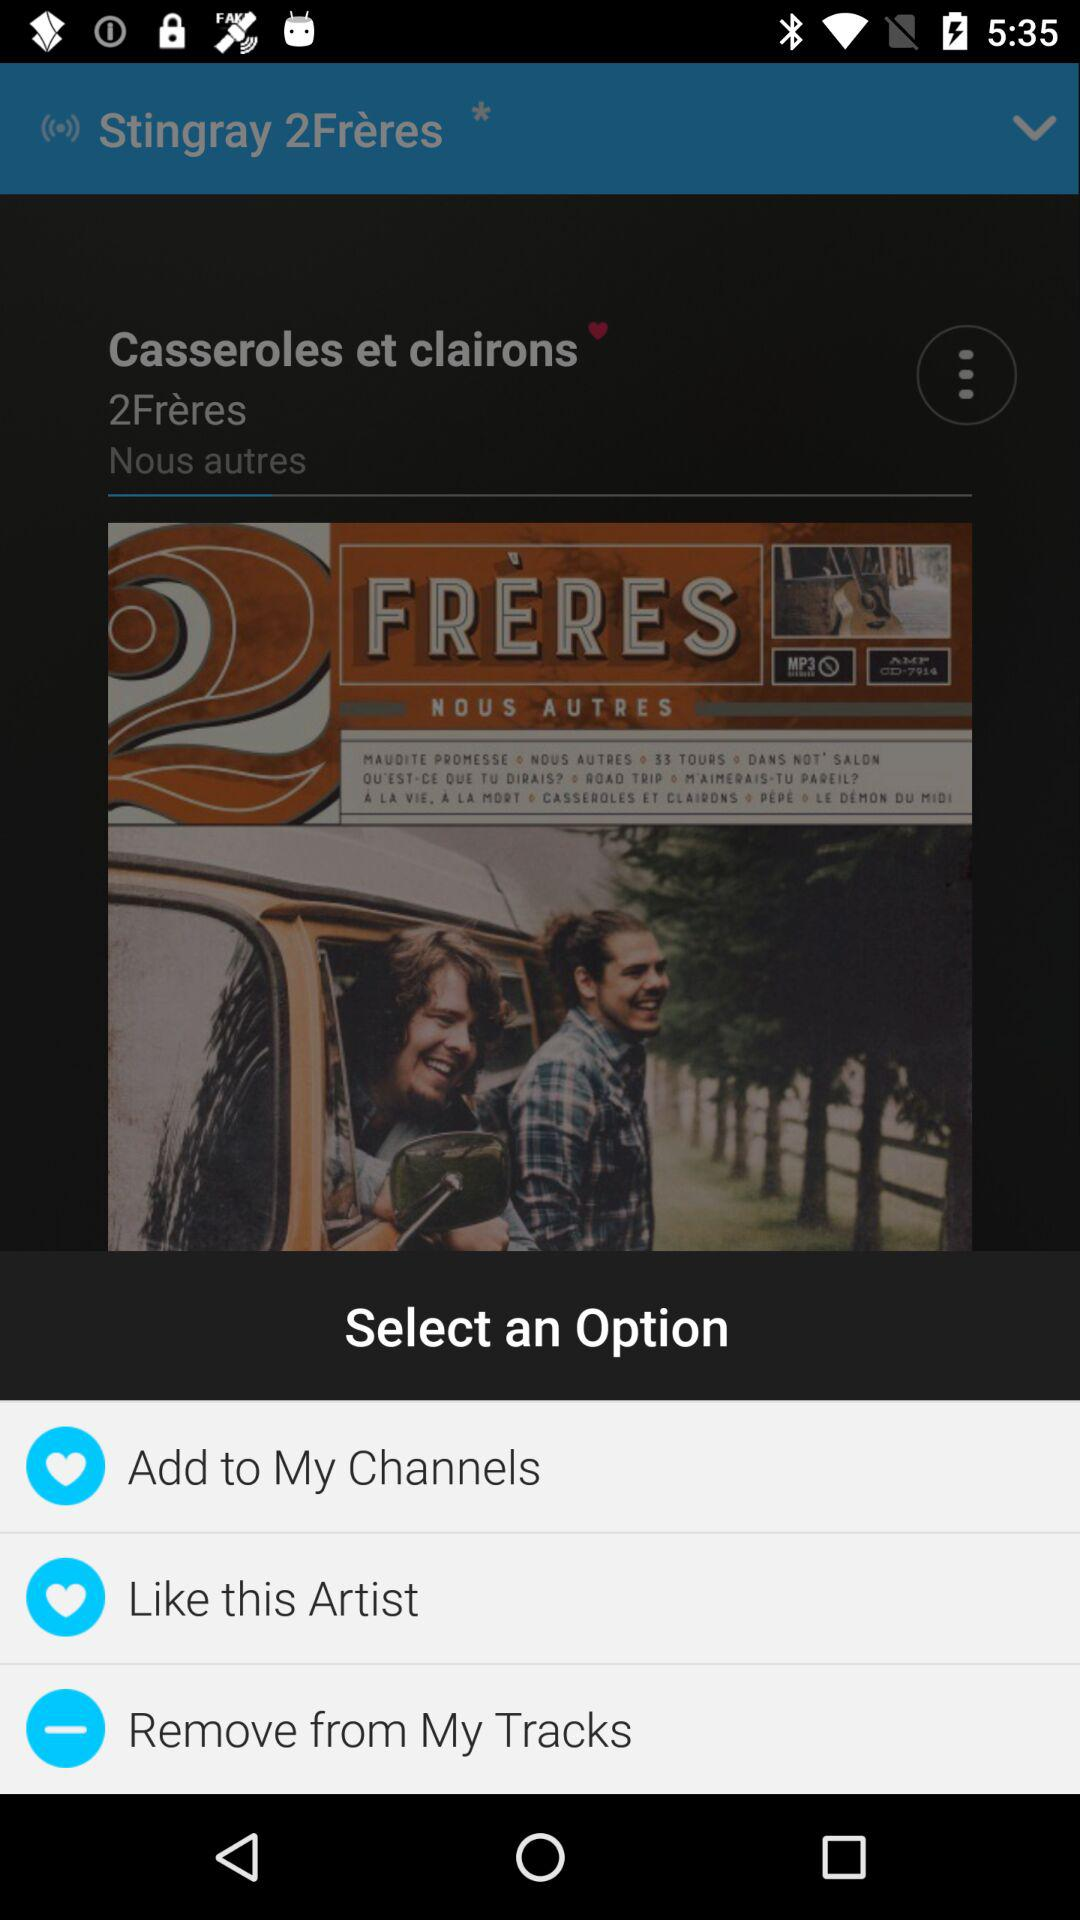How many options are available for the user to choose from?
Answer the question using a single word or phrase. 3 